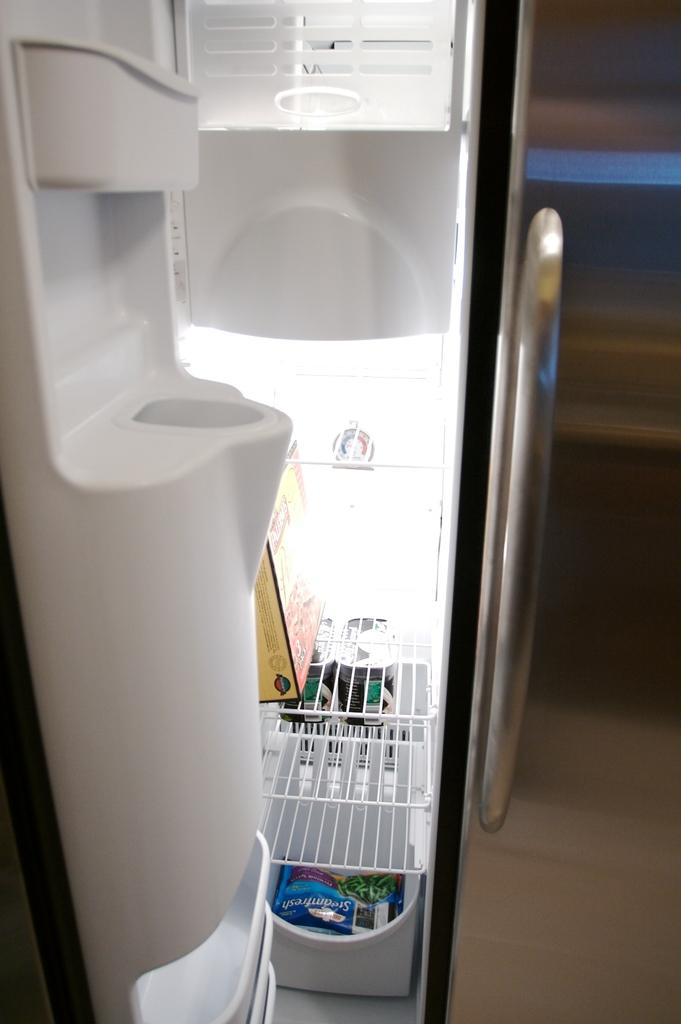Provide a one-sentence caption for the provided image. A near empty freezer has a bag of SteamFresh green beans on the bottom shelf. 